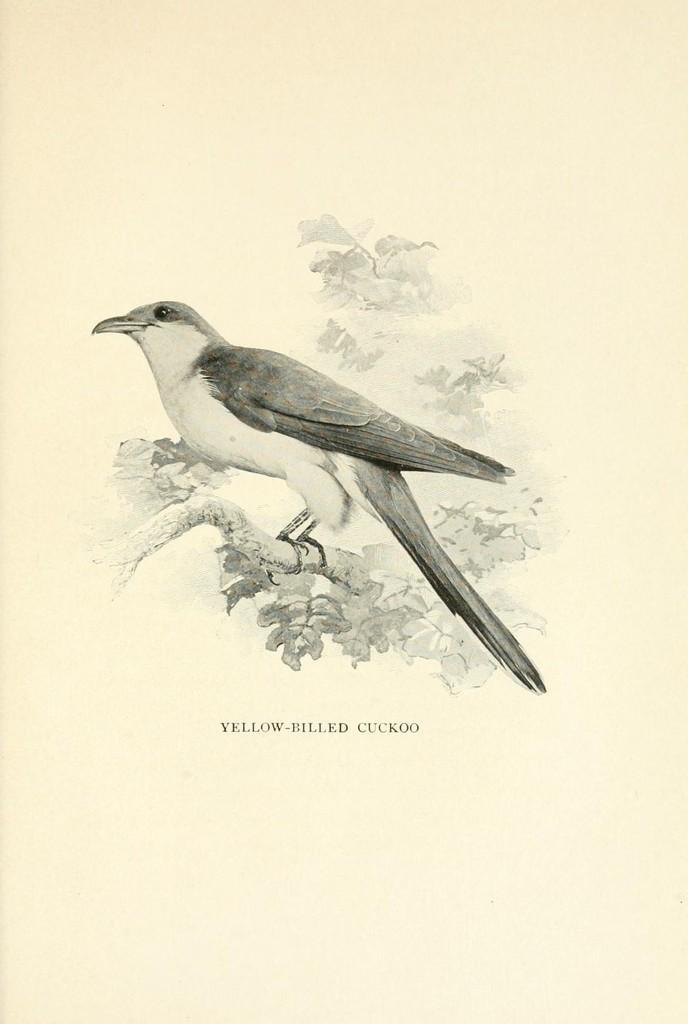Describe this image in one or two sentences. In this image we can see the black and white picture of a bird on the branch of a tree. We can also see some text on this image. 